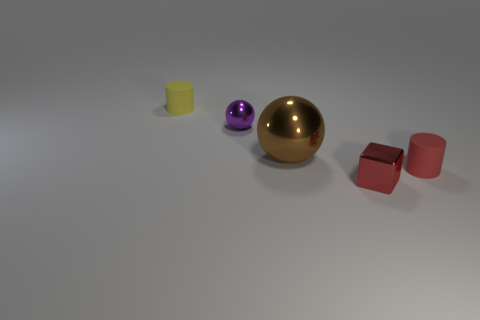Is there any other thing that is the same size as the brown shiny object?
Ensure brevity in your answer.  No. How many matte things are either big purple cylinders or purple spheres?
Your answer should be compact. 0. What is the material of the small yellow thing?
Make the answer very short. Rubber. There is a red cube; how many small cubes are right of it?
Give a very brief answer. 0. Does the tiny cylinder right of the large brown metallic ball have the same material as the tiny yellow thing?
Your response must be concise. Yes. How many brown shiny things are the same shape as the tiny purple thing?
Provide a succinct answer. 1. How many large objects are matte objects or yellow spheres?
Offer a terse response. 0. There is a tiny object that is to the right of the block; does it have the same color as the large ball?
Your response must be concise. No. There is a cylinder that is behind the large brown metal thing; is it the same color as the rubber thing that is in front of the small yellow object?
Offer a terse response. No. Are there any red cubes made of the same material as the big thing?
Ensure brevity in your answer.  Yes. 